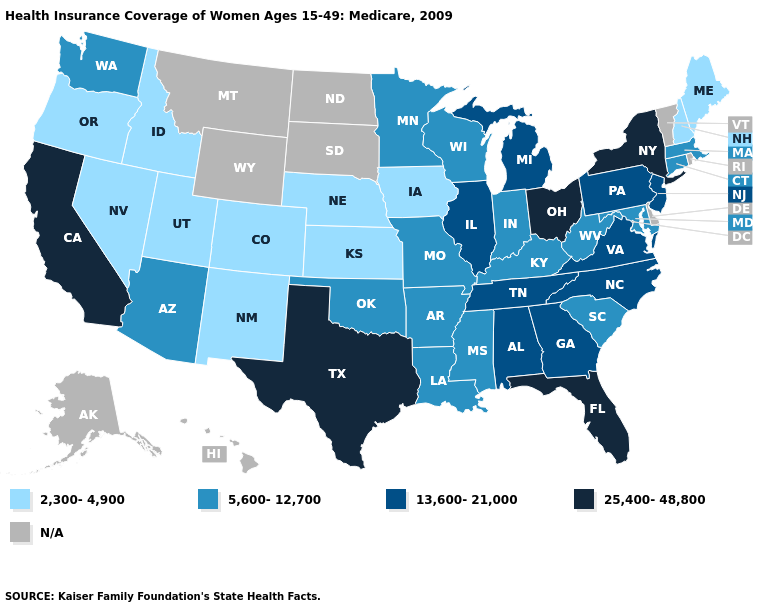Does Connecticut have the lowest value in the Northeast?
Keep it brief. No. Does Oregon have the lowest value in the USA?
Answer briefly. Yes. Name the states that have a value in the range 25,400-48,800?
Give a very brief answer. California, Florida, New York, Ohio, Texas. What is the value of Alabama?
Keep it brief. 13,600-21,000. What is the value of Arkansas?
Concise answer only. 5,600-12,700. Among the states that border North Carolina , does South Carolina have the highest value?
Keep it brief. No. What is the value of Michigan?
Give a very brief answer. 13,600-21,000. Name the states that have a value in the range N/A?
Write a very short answer. Alaska, Delaware, Hawaii, Montana, North Dakota, Rhode Island, South Dakota, Vermont, Wyoming. What is the lowest value in the USA?
Concise answer only. 2,300-4,900. Does Washington have the highest value in the USA?
Quick response, please. No. How many symbols are there in the legend?
Concise answer only. 5. Among the states that border Iowa , which have the highest value?
Concise answer only. Illinois. What is the highest value in the USA?
Concise answer only. 25,400-48,800. What is the value of Arkansas?
Concise answer only. 5,600-12,700. What is the highest value in the USA?
Be succinct. 25,400-48,800. 